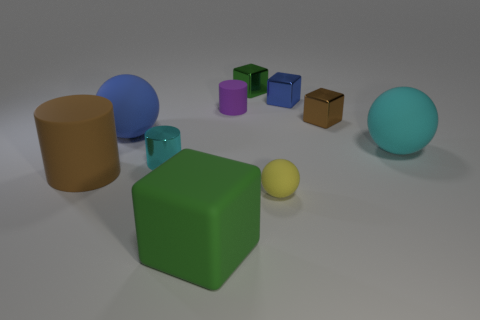Add 1 large cyan rubber objects. How many large cyan rubber objects exist? 2 Subtract all green blocks. How many blocks are left? 2 Subtract all large balls. How many balls are left? 1 Subtract 0 yellow cylinders. How many objects are left? 10 Subtract all balls. How many objects are left? 7 Subtract 4 blocks. How many blocks are left? 0 Subtract all yellow cubes. Subtract all blue cylinders. How many cubes are left? 4 Subtract all red blocks. How many cyan spheres are left? 1 Subtract all green spheres. Subtract all tiny purple rubber cylinders. How many objects are left? 9 Add 7 big rubber spheres. How many big rubber spheres are left? 9 